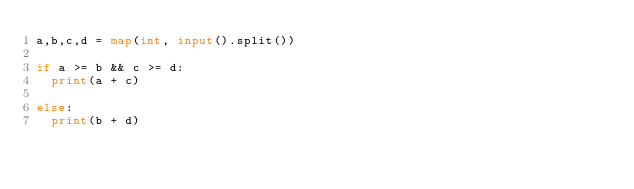Convert code to text. <code><loc_0><loc_0><loc_500><loc_500><_Python_>a,b,c,d = map(int, input().split())

if a >= b && c >= d:
  print(a + c)
  
else:
  print(b + d)</code> 